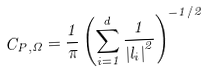<formula> <loc_0><loc_0><loc_500><loc_500>C _ { P , \Omega } = \frac { 1 } { \pi } \left ( \sum _ { i = 1 } ^ { d } \frac { 1 } { \left | l _ { i } \right | ^ { 2 } } \right ) ^ { - 1 / 2 }</formula> 